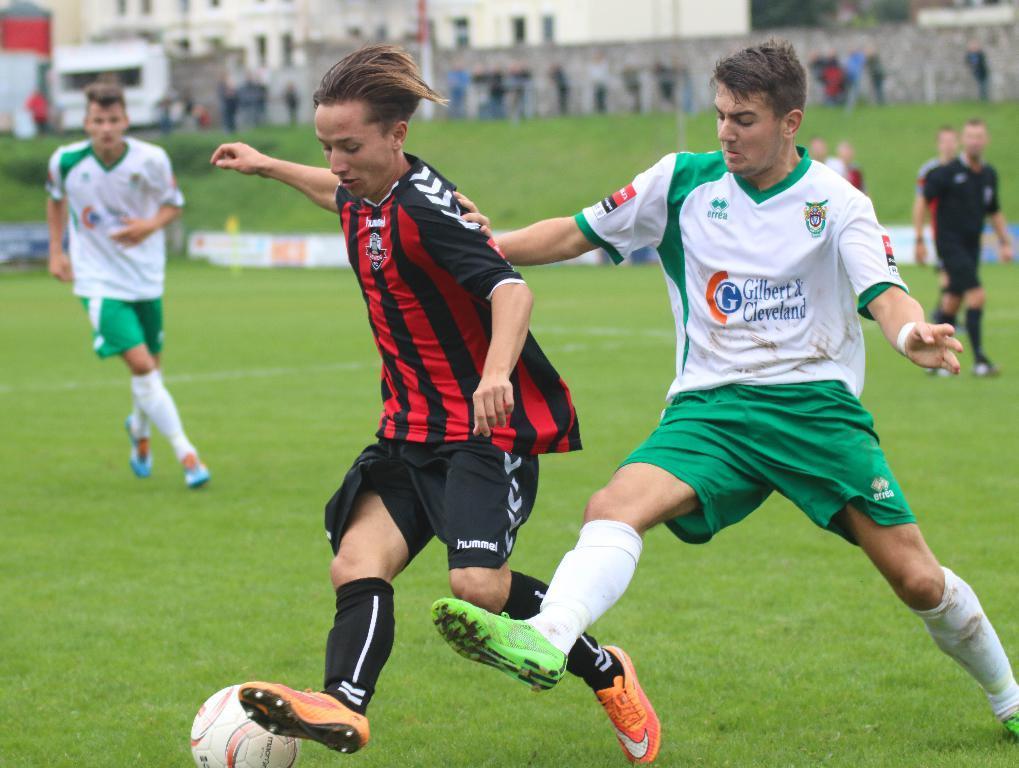Could you give a brief overview of what you see in this image? This picture shows people playing football on a green field and we see few buildings. 